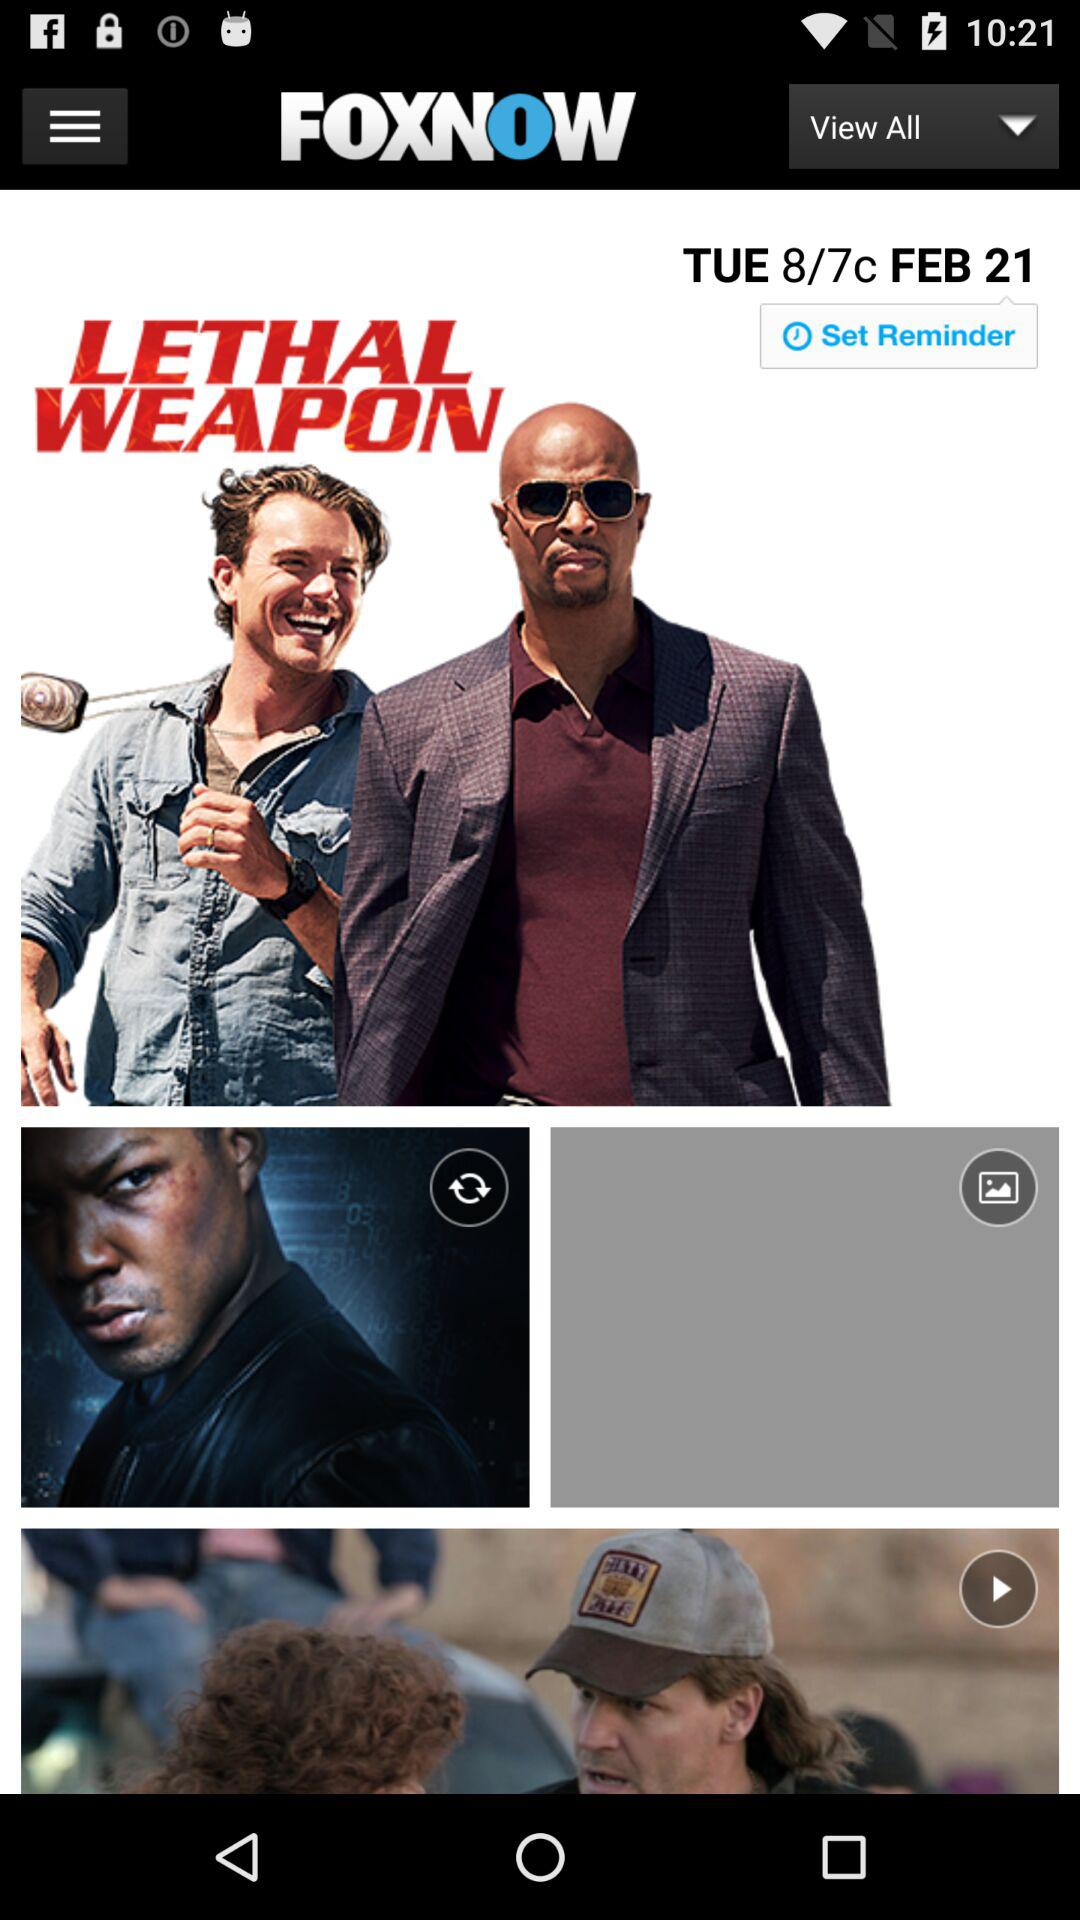What is the application name? The name of the application is "FOXNOW". 